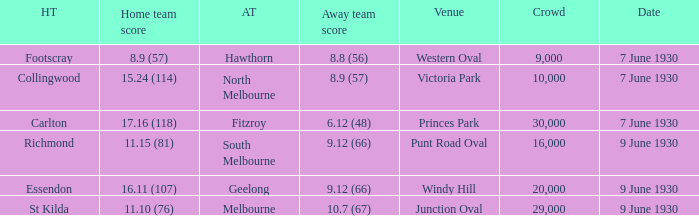What is the average crowd size when North Melbourne is the away team? 10000.0. 